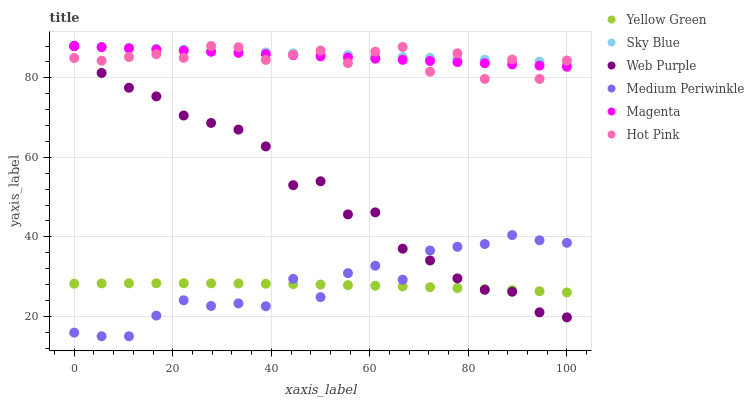Does Yellow Green have the minimum area under the curve?
Answer yes or no. Yes. Does Sky Blue have the maximum area under the curve?
Answer yes or no. Yes. Does Hot Pink have the minimum area under the curve?
Answer yes or no. No. Does Hot Pink have the maximum area under the curve?
Answer yes or no. No. Is Sky Blue the smoothest?
Answer yes or no. Yes. Is Hot Pink the roughest?
Answer yes or no. Yes. Is Medium Periwinkle the smoothest?
Answer yes or no. No. Is Medium Periwinkle the roughest?
Answer yes or no. No. Does Medium Periwinkle have the lowest value?
Answer yes or no. Yes. Does Hot Pink have the lowest value?
Answer yes or no. No. Does Magenta have the highest value?
Answer yes or no. Yes. Does Medium Periwinkle have the highest value?
Answer yes or no. No. Is Yellow Green less than Hot Pink?
Answer yes or no. Yes. Is Sky Blue greater than Yellow Green?
Answer yes or no. Yes. Does Medium Periwinkle intersect Web Purple?
Answer yes or no. Yes. Is Medium Periwinkle less than Web Purple?
Answer yes or no. No. Is Medium Periwinkle greater than Web Purple?
Answer yes or no. No. Does Yellow Green intersect Hot Pink?
Answer yes or no. No. 